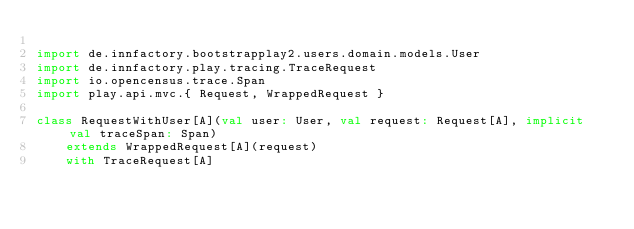Convert code to text. <code><loc_0><loc_0><loc_500><loc_500><_Scala_>
import de.innfactory.bootstrapplay2.users.domain.models.User
import de.innfactory.play.tracing.TraceRequest
import io.opencensus.trace.Span
import play.api.mvc.{ Request, WrappedRequest }

class RequestWithUser[A](val user: User, val request: Request[A], implicit val traceSpan: Span)
    extends WrappedRequest[A](request)
    with TraceRequest[A]
</code> 